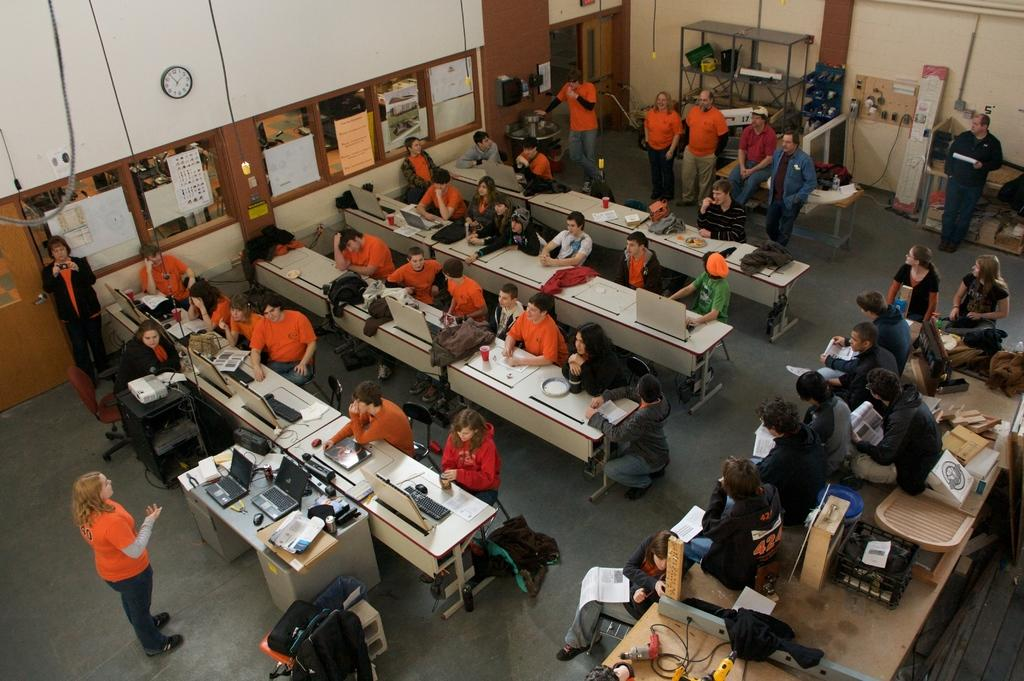What are the people in the image doing? There is a group of people seated on chairs, and some people are standing. A woman is standing and speaking. What objects are on the table in the image? There are laptops on the table. What electronic devices are present in the image? There are monitors present in the image. What is the profit margin of the furniture company in the image? There is no mention of a furniture company or profit margin in the image. How do the people in the image react to the woman's speech? The image does not show the reactions of the people to the woman's speech. 